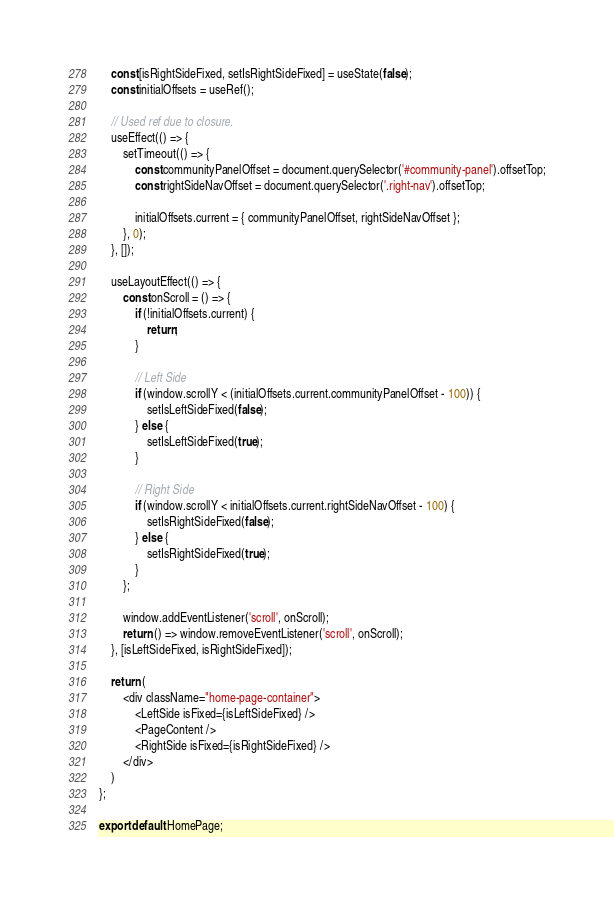Convert code to text. <code><loc_0><loc_0><loc_500><loc_500><_JavaScript_>    const [isRightSideFixed, setIsRightSideFixed] = useState(false);
    const initialOffsets = useRef();

    // Used ref due to closure.
    useEffect(() => {
        setTimeout(() => {
            const communityPanelOffset = document.querySelector('#community-panel').offsetTop;
            const rightSideNavOffset = document.querySelector('.right-nav').offsetTop;

            initialOffsets.current = { communityPanelOffset, rightSideNavOffset };
        }, 0);
    }, []);

    useLayoutEffect(() => {
        const onScroll = () => {
            if (!initialOffsets.current) {
                return;
            }

            // Left Side
            if (window.scrollY < (initialOffsets.current.communityPanelOffset - 100)) {
                setIsLeftSideFixed(false);
            } else {
                setIsLeftSideFixed(true);
            }

            // Right Side
            if (window.scrollY < initialOffsets.current.rightSideNavOffset - 100) {
                setIsRightSideFixed(false);
            } else {
                setIsRightSideFixed(true);
            }
        };

        window.addEventListener('scroll', onScroll);
        return () => window.removeEventListener('scroll', onScroll);
    }, [isLeftSideFixed, isRightSideFixed]);

    return (
        <div className="home-page-container">
            <LeftSide isFixed={isLeftSideFixed} />
            <PageContent />
            <RightSide isFixed={isRightSideFixed} />
        </div>
    )
};

export default HomePage;</code> 